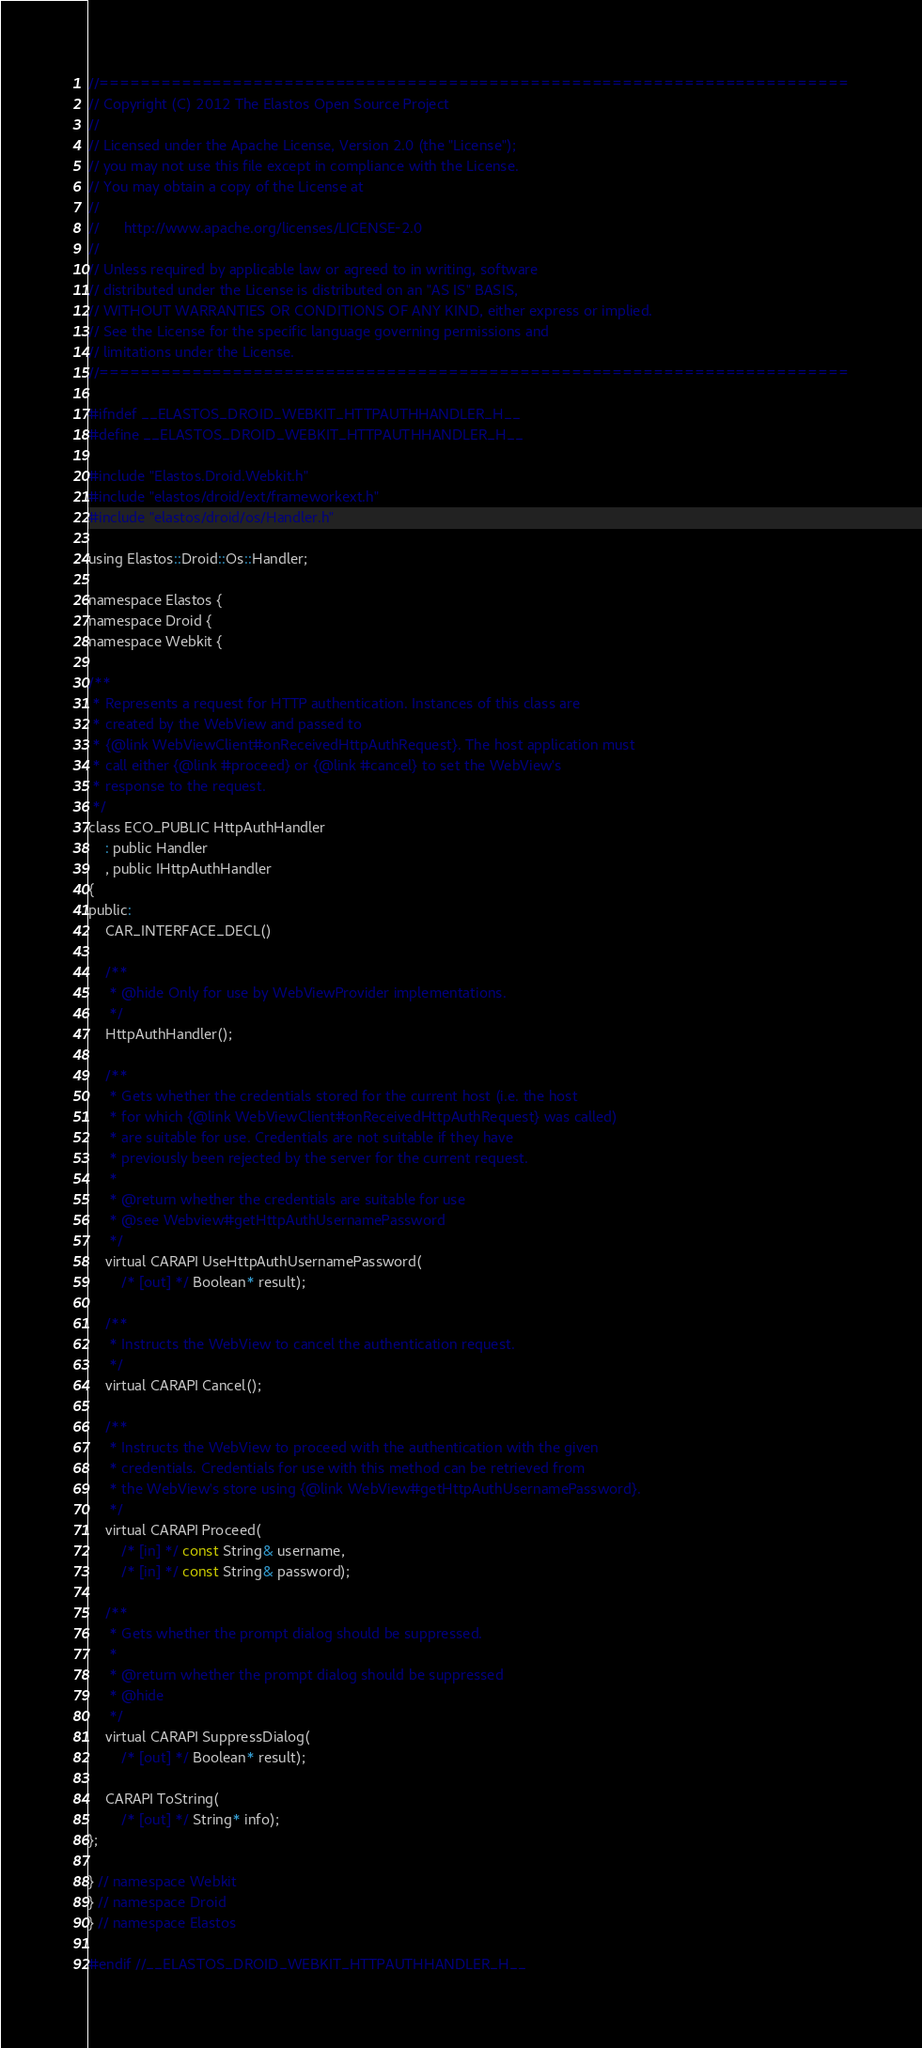<code> <loc_0><loc_0><loc_500><loc_500><_C_>//=========================================================================
// Copyright (C) 2012 The Elastos Open Source Project
//
// Licensed under the Apache License, Version 2.0 (the "License");
// you may not use this file except in compliance with the License.
// You may obtain a copy of the License at
//
//      http://www.apache.org/licenses/LICENSE-2.0
//
// Unless required by applicable law or agreed to in writing, software
// distributed under the License is distributed on an "AS IS" BASIS,
// WITHOUT WARRANTIES OR CONDITIONS OF ANY KIND, either express or implied.
// See the License for the specific language governing permissions and
// limitations under the License.
//=========================================================================

#ifndef __ELASTOS_DROID_WEBKIT_HTTPAUTHHANDLER_H__
#define __ELASTOS_DROID_WEBKIT_HTTPAUTHHANDLER_H__

#include "Elastos.Droid.Webkit.h"
#include "elastos/droid/ext/frameworkext.h"
#include "elastos/droid/os/Handler.h"

using Elastos::Droid::Os::Handler;

namespace Elastos {
namespace Droid {
namespace Webkit {

/**
 * Represents a request for HTTP authentication. Instances of this class are
 * created by the WebView and passed to
 * {@link WebViewClient#onReceivedHttpAuthRequest}. The host application must
 * call either {@link #proceed} or {@link #cancel} to set the WebView's
 * response to the request.
 */
class ECO_PUBLIC HttpAuthHandler
    : public Handler
    , public IHttpAuthHandler
{
public:
    CAR_INTERFACE_DECL()

    /**
     * @hide Only for use by WebViewProvider implementations.
     */
    HttpAuthHandler();

    /**
     * Gets whether the credentials stored for the current host (i.e. the host
     * for which {@link WebViewClient#onReceivedHttpAuthRequest} was called)
     * are suitable for use. Credentials are not suitable if they have
     * previously been rejected by the server for the current request.
     *
     * @return whether the credentials are suitable for use
     * @see Webview#getHttpAuthUsernamePassword
     */
    virtual CARAPI UseHttpAuthUsernamePassword(
        /* [out] */ Boolean* result);

    /**
     * Instructs the WebView to cancel the authentication request.
     */
    virtual CARAPI Cancel();

    /**
     * Instructs the WebView to proceed with the authentication with the given
     * credentials. Credentials for use with this method can be retrieved from
     * the WebView's store using {@link WebView#getHttpAuthUsernamePassword}.
     */
    virtual CARAPI Proceed(
        /* [in] */ const String& username,
        /* [in] */ const String& password);

    /**
     * Gets whether the prompt dialog should be suppressed.
     *
     * @return whether the prompt dialog should be suppressed
     * @hide
     */
    virtual CARAPI SuppressDialog(
        /* [out] */ Boolean* result);

    CARAPI ToString(
        /* [out] */ String* info);
};

} // namespace Webkit
} // namespace Droid
} // namespace Elastos

#endif //__ELASTOS_DROID_WEBKIT_HTTPAUTHHANDLER_H__
</code> 